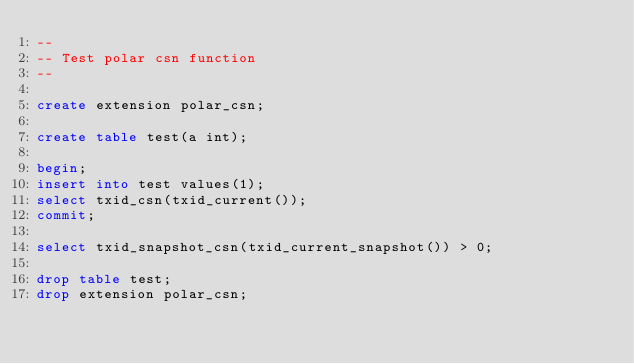<code> <loc_0><loc_0><loc_500><loc_500><_SQL_>--
-- Test polar csn function
--

create extension polar_csn;

create table test(a int);

begin;
insert into test values(1);
select txid_csn(txid_current());
commit;

select txid_snapshot_csn(txid_current_snapshot()) > 0;

drop table test;
drop extension polar_csn;</code> 